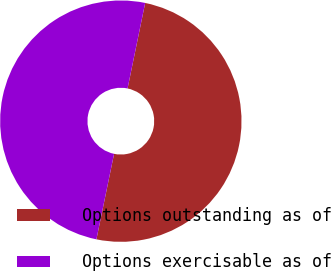Convert chart. <chart><loc_0><loc_0><loc_500><loc_500><pie_chart><fcel>Options outstanding as of<fcel>Options exercisable as of<nl><fcel>50.01%<fcel>49.99%<nl></chart> 